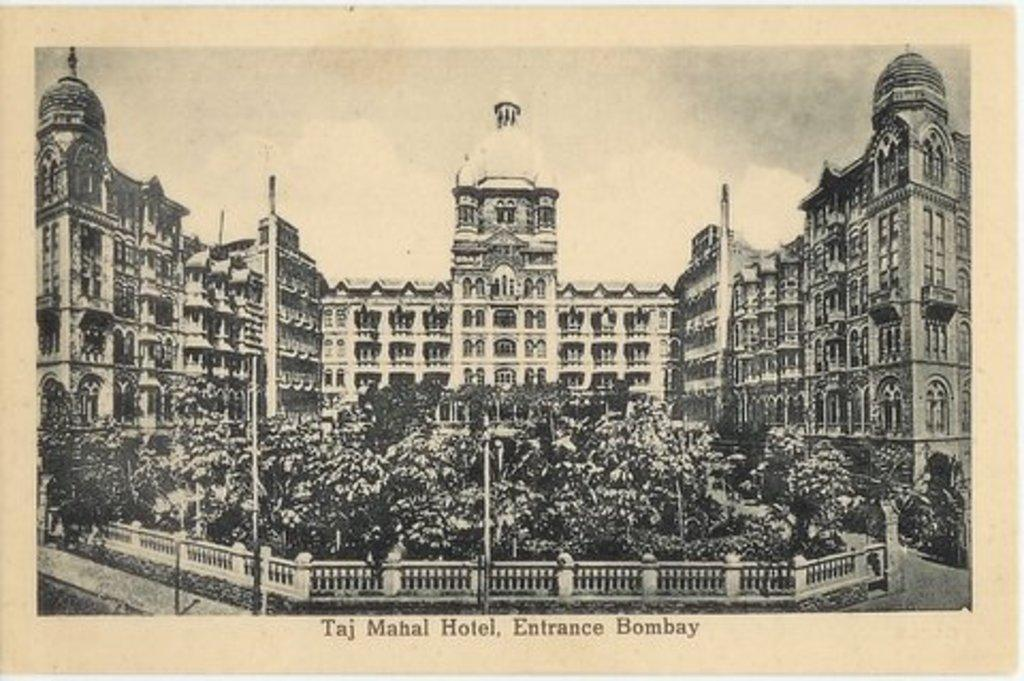<image>
Relay a brief, clear account of the picture shown. An old black and white postcard of the Taj Mahal Hotel 